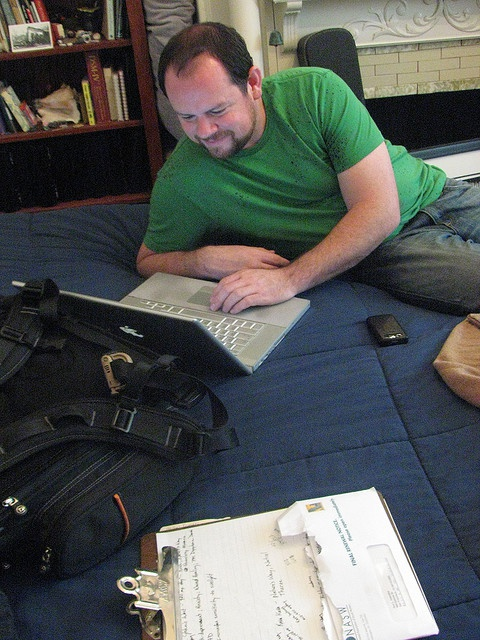Describe the objects in this image and their specific colors. I can see bed in darkgreen, navy, darkblue, black, and gray tones, people in darkgreen, black, and gray tones, backpack in darkgreen, black, gray, and darkblue tones, laptop in darkgreen, black, darkgray, and gray tones, and book in darkgreen, black, and gray tones in this image. 